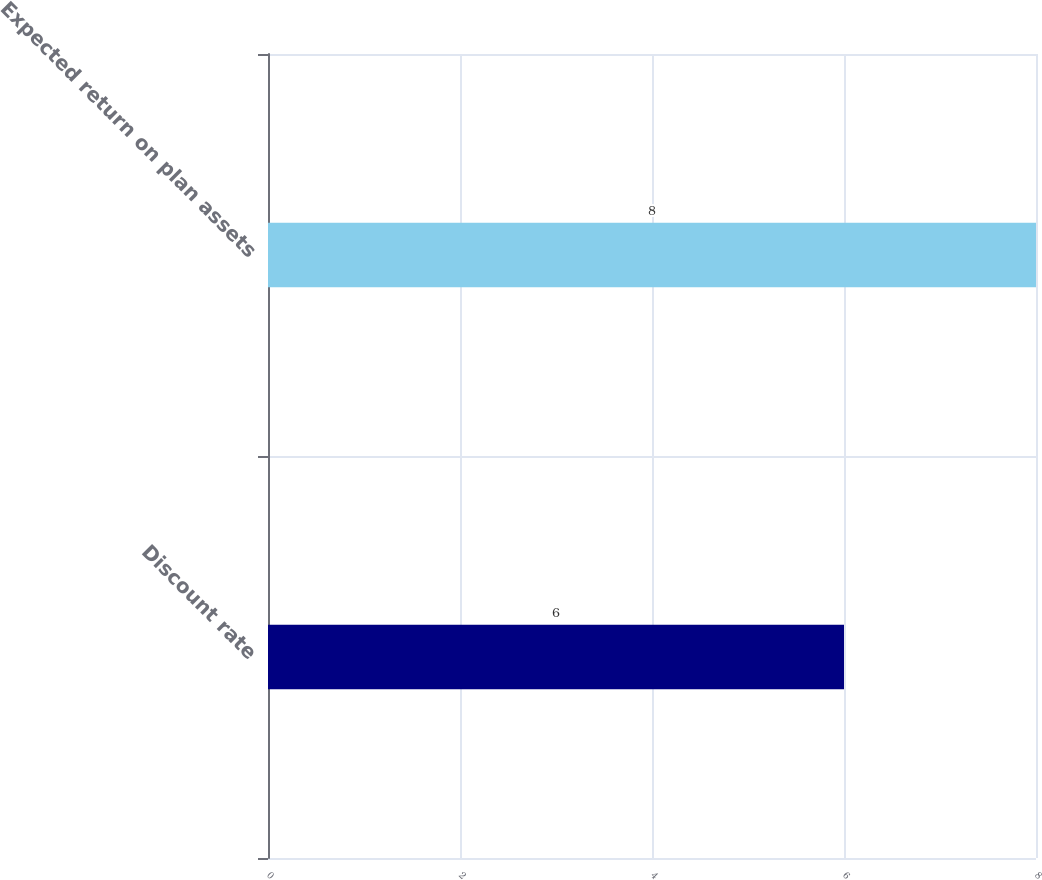Convert chart. <chart><loc_0><loc_0><loc_500><loc_500><bar_chart><fcel>Discount rate<fcel>Expected return on plan assets<nl><fcel>6<fcel>8<nl></chart> 